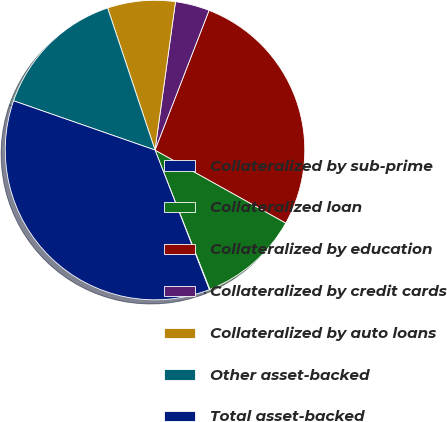Convert chart. <chart><loc_0><loc_0><loc_500><loc_500><pie_chart><fcel>Collateralized by sub-prime<fcel>Collateralized loan<fcel>Collateralized by education<fcel>Collateralized by credit cards<fcel>Collateralized by auto loans<fcel>Other asset-backed<fcel>Total asset-backed<nl><fcel>0.07%<fcel>10.92%<fcel>27.23%<fcel>3.69%<fcel>7.31%<fcel>14.54%<fcel>36.24%<nl></chart> 